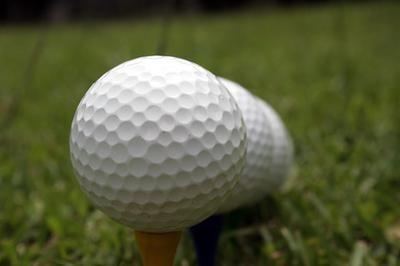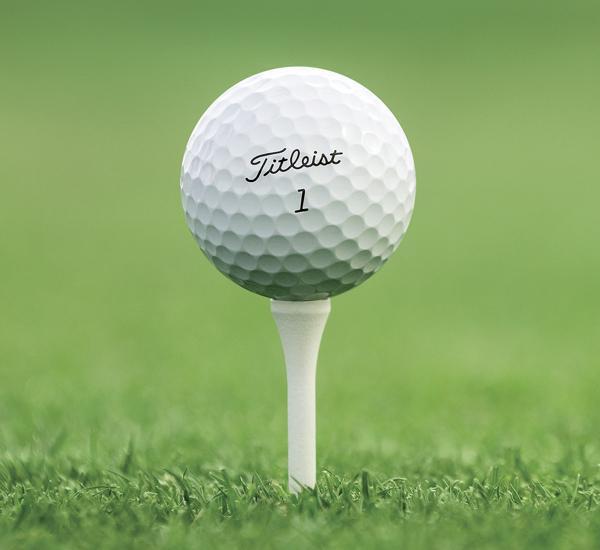The first image is the image on the left, the second image is the image on the right. Analyze the images presented: Is the assertion "The ball in the image on the right is sitting on a white tee." valid? Answer yes or no. Yes. The first image is the image on the left, the second image is the image on the right. Given the left and right images, does the statement "Right image shows one white golf ball perched on a tee." hold true? Answer yes or no. Yes. 